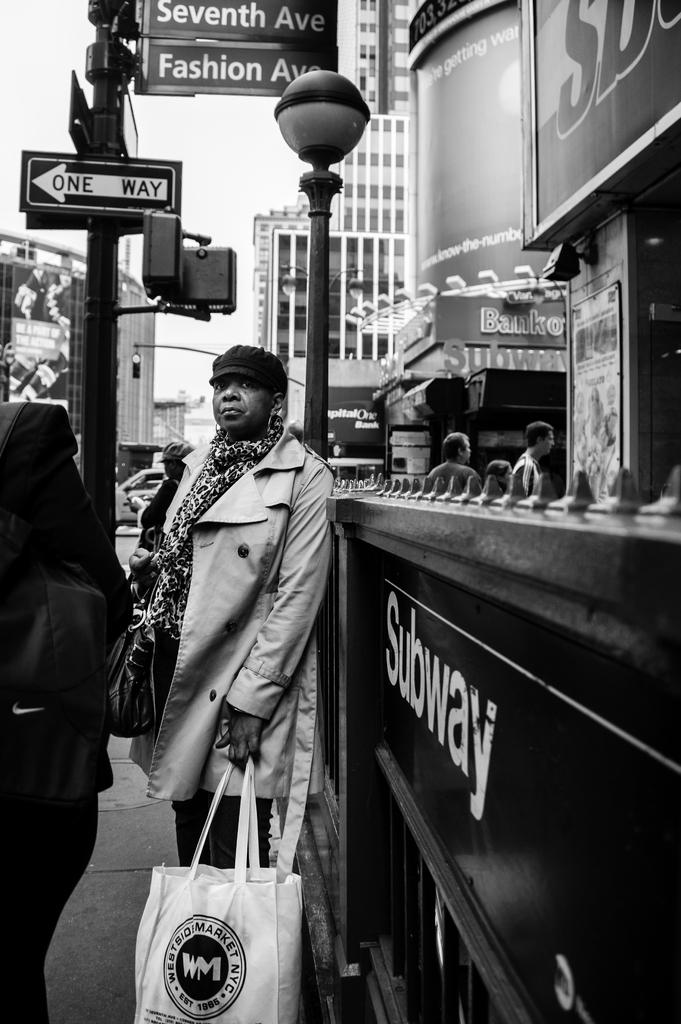What is the main subject of the image? There is a woman in the image. What is the woman doing in the image? The woman is standing in the image. What is the woman holding in her hand? The woman is holding a bag in her hand. What can be seen in the background of the image? There are boards on a pole, buildings, and people in the background of the image. How many crows are sitting on the woman's shoulder in the image? There are no crows present in the image. What type of cushion is the woman sitting on in the image? The woman is standing in the image, so there is no cushion for her to sit on. 